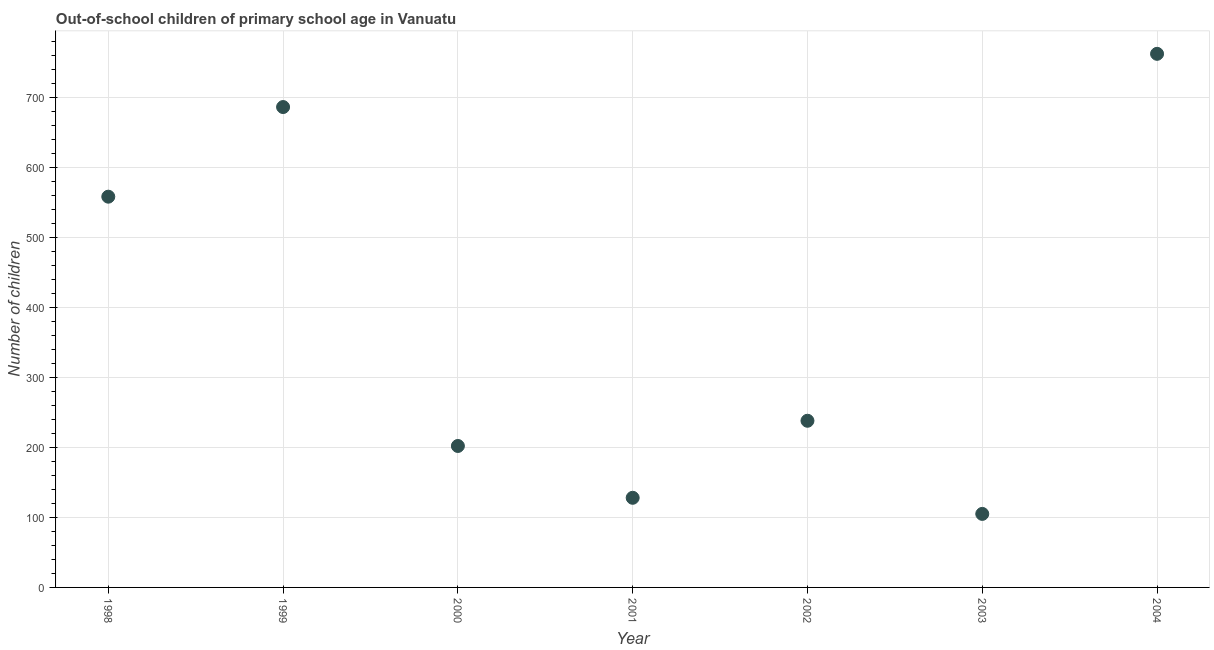What is the number of out-of-school children in 2004?
Make the answer very short. 762. Across all years, what is the maximum number of out-of-school children?
Provide a short and direct response. 762. Across all years, what is the minimum number of out-of-school children?
Your response must be concise. 105. What is the sum of the number of out-of-school children?
Your response must be concise. 2679. What is the difference between the number of out-of-school children in 2001 and 2003?
Offer a terse response. 23. What is the average number of out-of-school children per year?
Give a very brief answer. 382.71. What is the median number of out-of-school children?
Keep it short and to the point. 238. Do a majority of the years between 2000 and 2004 (inclusive) have number of out-of-school children greater than 180 ?
Provide a succinct answer. Yes. What is the ratio of the number of out-of-school children in 1998 to that in 2002?
Your answer should be compact. 2.34. Is the number of out-of-school children in 2000 less than that in 2004?
Your answer should be compact. Yes. Is the difference between the number of out-of-school children in 2001 and 2002 greater than the difference between any two years?
Offer a terse response. No. Is the sum of the number of out-of-school children in 2000 and 2002 greater than the maximum number of out-of-school children across all years?
Offer a terse response. No. What is the difference between the highest and the lowest number of out-of-school children?
Your answer should be compact. 657. How many dotlines are there?
Make the answer very short. 1. How many years are there in the graph?
Your answer should be very brief. 7. What is the title of the graph?
Your answer should be very brief. Out-of-school children of primary school age in Vanuatu. What is the label or title of the Y-axis?
Offer a very short reply. Number of children. What is the Number of children in 1998?
Ensure brevity in your answer.  558. What is the Number of children in 1999?
Your answer should be very brief. 686. What is the Number of children in 2000?
Your answer should be very brief. 202. What is the Number of children in 2001?
Your answer should be very brief. 128. What is the Number of children in 2002?
Your answer should be very brief. 238. What is the Number of children in 2003?
Make the answer very short. 105. What is the Number of children in 2004?
Offer a very short reply. 762. What is the difference between the Number of children in 1998 and 1999?
Make the answer very short. -128. What is the difference between the Number of children in 1998 and 2000?
Make the answer very short. 356. What is the difference between the Number of children in 1998 and 2001?
Give a very brief answer. 430. What is the difference between the Number of children in 1998 and 2002?
Offer a terse response. 320. What is the difference between the Number of children in 1998 and 2003?
Your answer should be very brief. 453. What is the difference between the Number of children in 1998 and 2004?
Your answer should be very brief. -204. What is the difference between the Number of children in 1999 and 2000?
Your response must be concise. 484. What is the difference between the Number of children in 1999 and 2001?
Your answer should be very brief. 558. What is the difference between the Number of children in 1999 and 2002?
Provide a succinct answer. 448. What is the difference between the Number of children in 1999 and 2003?
Ensure brevity in your answer.  581. What is the difference between the Number of children in 1999 and 2004?
Offer a very short reply. -76. What is the difference between the Number of children in 2000 and 2001?
Give a very brief answer. 74. What is the difference between the Number of children in 2000 and 2002?
Ensure brevity in your answer.  -36. What is the difference between the Number of children in 2000 and 2003?
Provide a succinct answer. 97. What is the difference between the Number of children in 2000 and 2004?
Make the answer very short. -560. What is the difference between the Number of children in 2001 and 2002?
Offer a terse response. -110. What is the difference between the Number of children in 2001 and 2003?
Keep it short and to the point. 23. What is the difference between the Number of children in 2001 and 2004?
Keep it short and to the point. -634. What is the difference between the Number of children in 2002 and 2003?
Provide a short and direct response. 133. What is the difference between the Number of children in 2002 and 2004?
Your answer should be very brief. -524. What is the difference between the Number of children in 2003 and 2004?
Provide a short and direct response. -657. What is the ratio of the Number of children in 1998 to that in 1999?
Offer a terse response. 0.81. What is the ratio of the Number of children in 1998 to that in 2000?
Give a very brief answer. 2.76. What is the ratio of the Number of children in 1998 to that in 2001?
Give a very brief answer. 4.36. What is the ratio of the Number of children in 1998 to that in 2002?
Provide a short and direct response. 2.35. What is the ratio of the Number of children in 1998 to that in 2003?
Make the answer very short. 5.31. What is the ratio of the Number of children in 1998 to that in 2004?
Your response must be concise. 0.73. What is the ratio of the Number of children in 1999 to that in 2000?
Keep it short and to the point. 3.4. What is the ratio of the Number of children in 1999 to that in 2001?
Offer a terse response. 5.36. What is the ratio of the Number of children in 1999 to that in 2002?
Offer a terse response. 2.88. What is the ratio of the Number of children in 1999 to that in 2003?
Your answer should be very brief. 6.53. What is the ratio of the Number of children in 2000 to that in 2001?
Provide a short and direct response. 1.58. What is the ratio of the Number of children in 2000 to that in 2002?
Keep it short and to the point. 0.85. What is the ratio of the Number of children in 2000 to that in 2003?
Give a very brief answer. 1.92. What is the ratio of the Number of children in 2000 to that in 2004?
Your response must be concise. 0.27. What is the ratio of the Number of children in 2001 to that in 2002?
Give a very brief answer. 0.54. What is the ratio of the Number of children in 2001 to that in 2003?
Provide a succinct answer. 1.22. What is the ratio of the Number of children in 2001 to that in 2004?
Give a very brief answer. 0.17. What is the ratio of the Number of children in 2002 to that in 2003?
Keep it short and to the point. 2.27. What is the ratio of the Number of children in 2002 to that in 2004?
Your answer should be very brief. 0.31. What is the ratio of the Number of children in 2003 to that in 2004?
Ensure brevity in your answer.  0.14. 